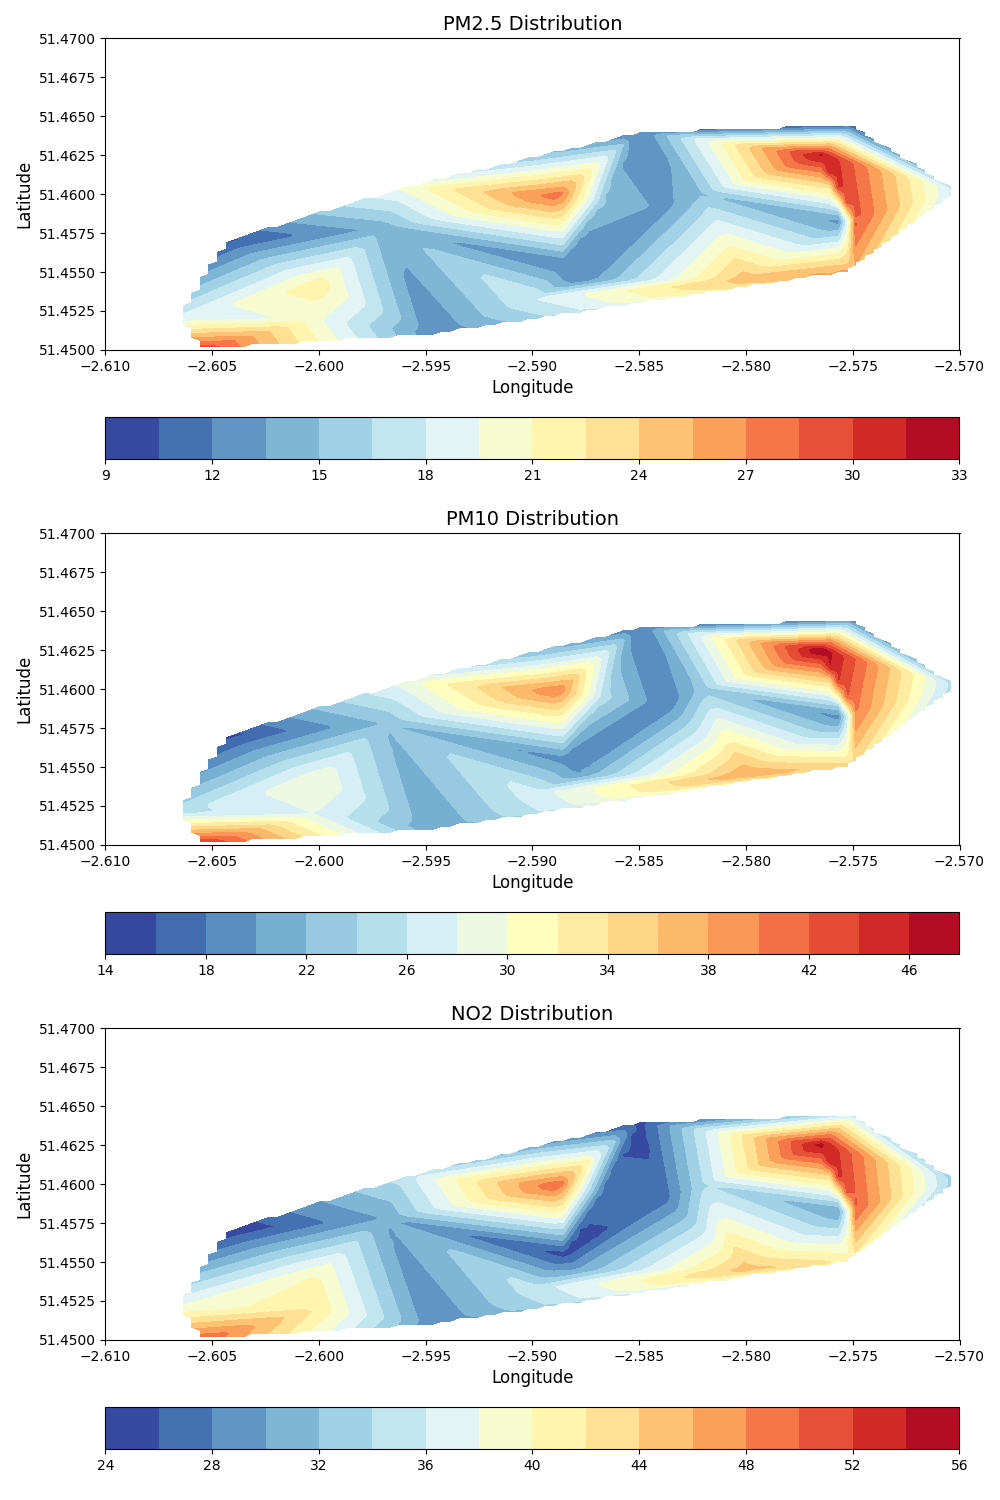Which pollutant has the highest concentration peak? To find this, look at the peak values in all three contour plots (PM2.5, PM10, and NO2). The NO2 plot shows the highest concentration since it goes up to 55.
Answer: NO2 Where is the highest concentration of PM2.5 located? By analyzing the PM2.5 contour plot, the highest concentration area is towards the lower middle section of the plot, around longitudes -2.5867 and latitudes 51.4595.
Answer: Lower middle section Is PM10 generally higher in the center of the city compared to its outer regions? Look at the distribution of PM10 in the contour plot: concentrations are higher toward the central region (around latitudes 51.455 to 51.460, longitudes -2.580 to -2.590), indicating central regions have higher PM10 values.
Answer: Yes Are the NO2 levels higher or lower compared to PM2.5 in the same location at the highest peak? Compare the NO2 and PM2.5 plots at the location with the highest concentration in the NO2 plot. The NO2 levels peak at 55, while PM2.5 peaks at 32 in the same location. This shows that NO2 levels are higher than PM2.5.
Answer: Higher Which season shows the highest overall air pollution level based on the combined pollutants? The highest values in the combined pollutant plots appear in July and August. Focus on these months for peaks in PM2.5, PM10, and NO2 to determine the highest collective levels.
Answer: July and August How does the location of highest NO2 concentration compare to PM10? By examining the contour plots for NO2 and PM10, you can see that the highest NO2 concentration overlaps with one of the highest areas for PM10 roughly around the same region near the center.
Answer: Similar location What is the range of PM2.5 concentrations in the city? By looking at the PM2.5 contour plot, the concentration ranges from the lowest (around 10) to the highest (around 32), providing the city's PM2.5 concentration span.
Answer: 10 to 32 Is the concentration of air pollutants generally higher in the northern or southern parts of Bristol? By evaluating all the contour plots, concentrations appear higher around the central-northern parts of Bristol (northern part covers higher values).
Answer: Northern parts What is the average peak concentration of PM10 and NO2 across the city? Calculate the mean of the highest values of PM10 and NO2. For PM10, the peak is around 48; for NO2, it is about 55. So, the average is (48+55)/2 = 51.5.
Answer: 51.5 In which part of the year does PM2.5 show a significant increase? Look at the PM2.5 contour plot and correlate it with dates: the months of April, July, and August show an increased concentration in PM2.5 values.
Answer: April, July, August 